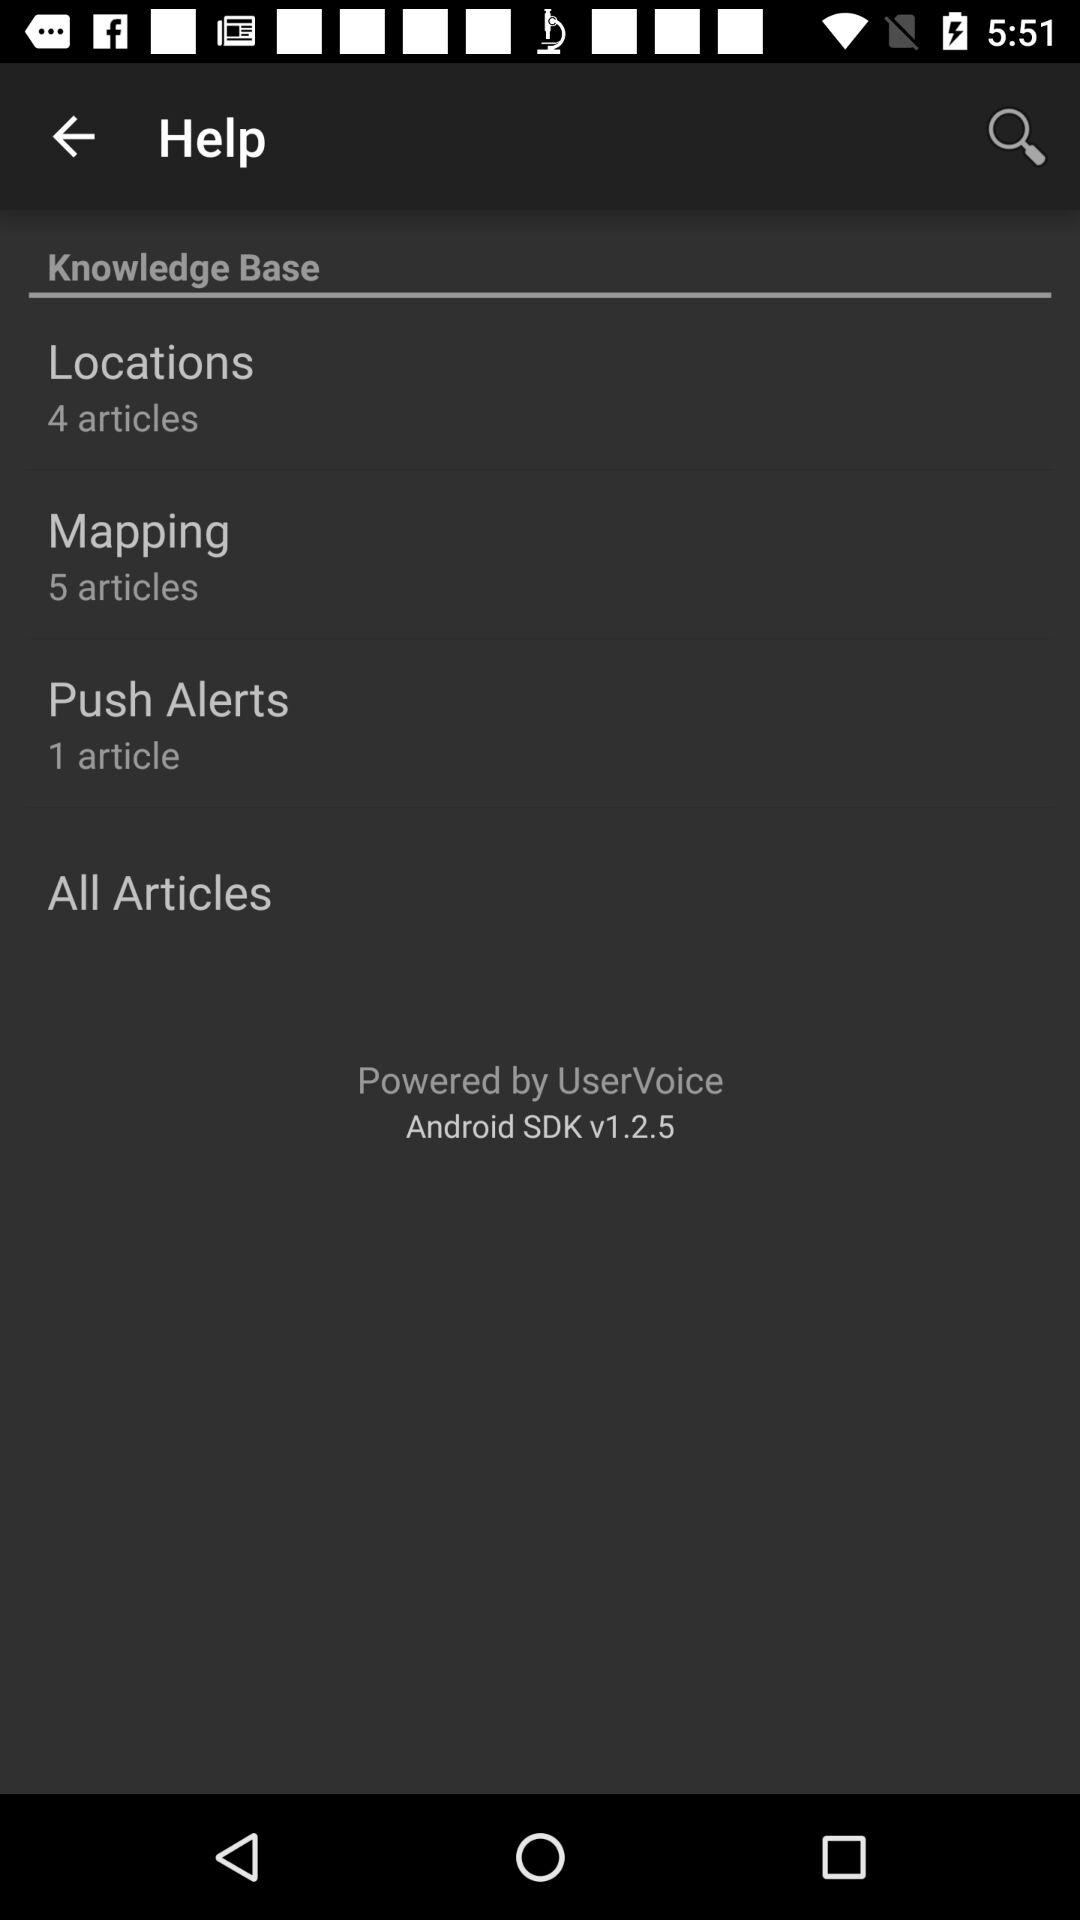Which Android version is available? The available Android version is v1.2.5. 